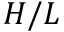<formula> <loc_0><loc_0><loc_500><loc_500>H / L</formula> 